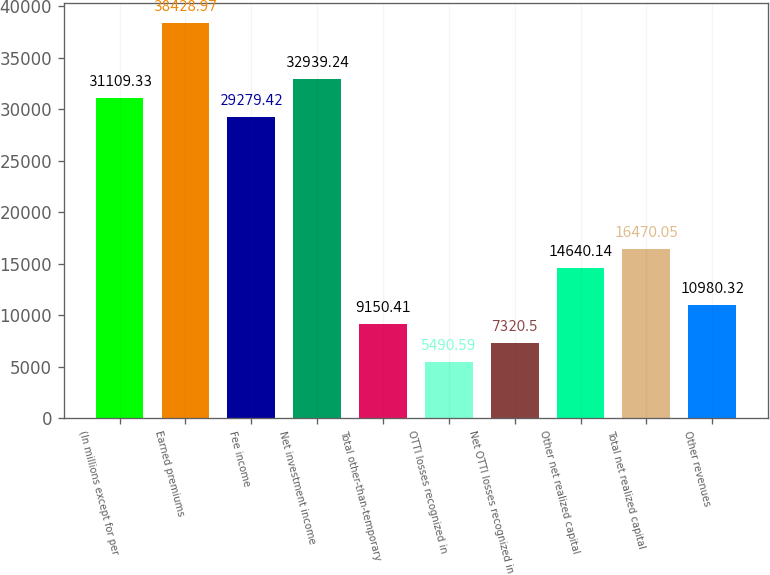Convert chart to OTSL. <chart><loc_0><loc_0><loc_500><loc_500><bar_chart><fcel>(In millions except for per<fcel>Earned premiums<fcel>Fee income<fcel>Net investment income<fcel>Total other-than-temporary<fcel>OTTI losses recognized in<fcel>Net OTTI losses recognized in<fcel>Other net realized capital<fcel>Total net realized capital<fcel>Other revenues<nl><fcel>31109.3<fcel>38429<fcel>29279.4<fcel>32939.2<fcel>9150.41<fcel>5490.59<fcel>7320.5<fcel>14640.1<fcel>16470<fcel>10980.3<nl></chart> 